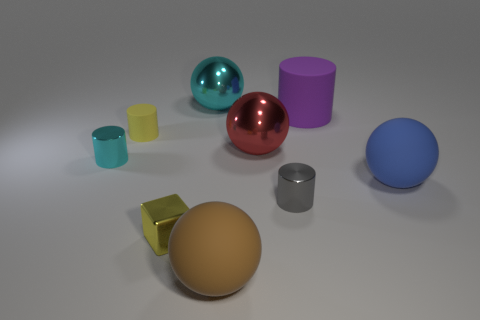Subtract all purple balls. Subtract all red cubes. How many balls are left? 4 Add 1 tiny purple things. How many objects exist? 10 Subtract all balls. How many objects are left? 5 Add 4 big blue balls. How many big blue balls are left? 5 Add 6 small cyan cylinders. How many small cyan cylinders exist? 7 Subtract 0 gray blocks. How many objects are left? 9 Subtract all brown objects. Subtract all tiny cyan things. How many objects are left? 7 